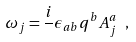Convert formula to latex. <formula><loc_0><loc_0><loc_500><loc_500>\omega _ { j } = \frac { i } { } \epsilon _ { a b } q ^ { b } A ^ { a } _ { j } \ ,</formula> 